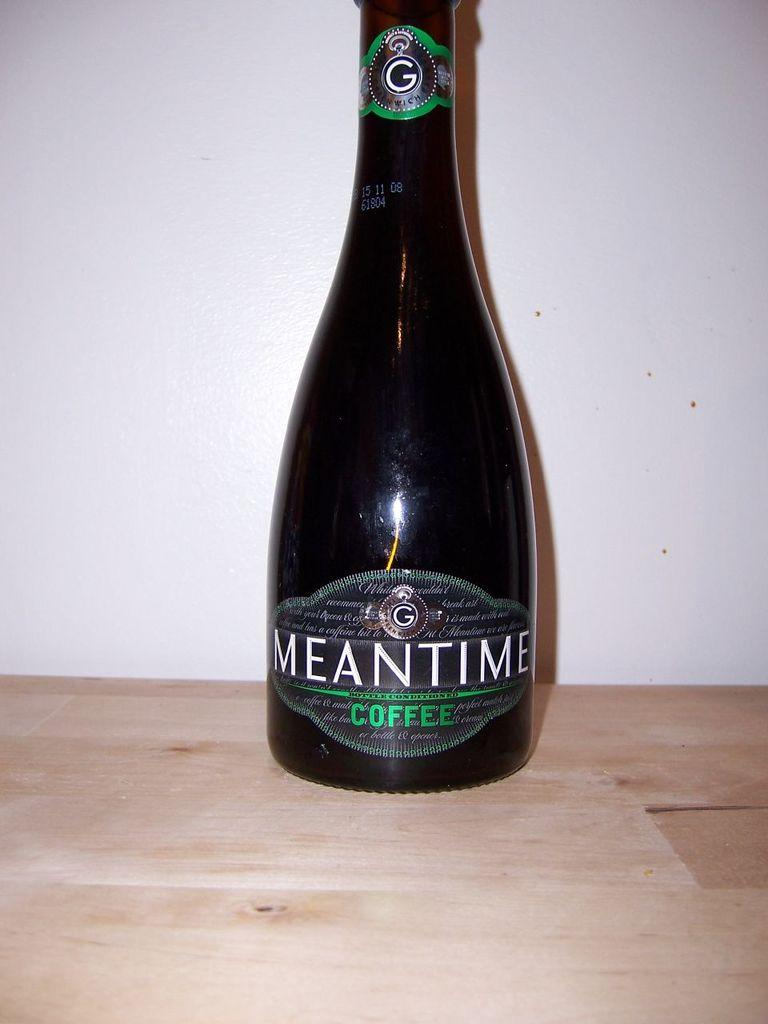<image>
Describe the image concisely. A bottle of Meantime Coffee on a wooden table. 